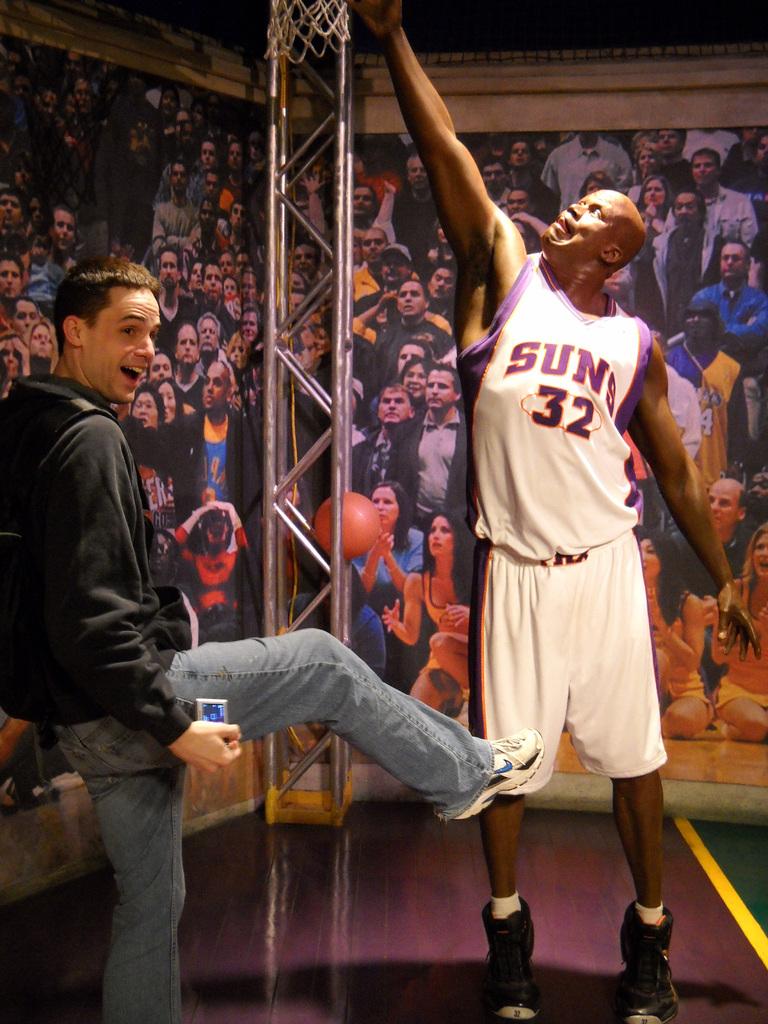What number is on the basketball player's shirt?
Provide a succinct answer. 32. 